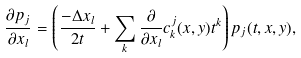<formula> <loc_0><loc_0><loc_500><loc_500>\frac { \partial p _ { j } } { \partial x _ { l } } = \left ( \frac { - \Delta x _ { l } } { 2 t } + \sum _ { k } \frac { \partial } { \partial x _ { l } } c ^ { j } _ { k } ( x , y ) t ^ { k } \right ) p _ { j } ( t , x , y ) ,</formula> 